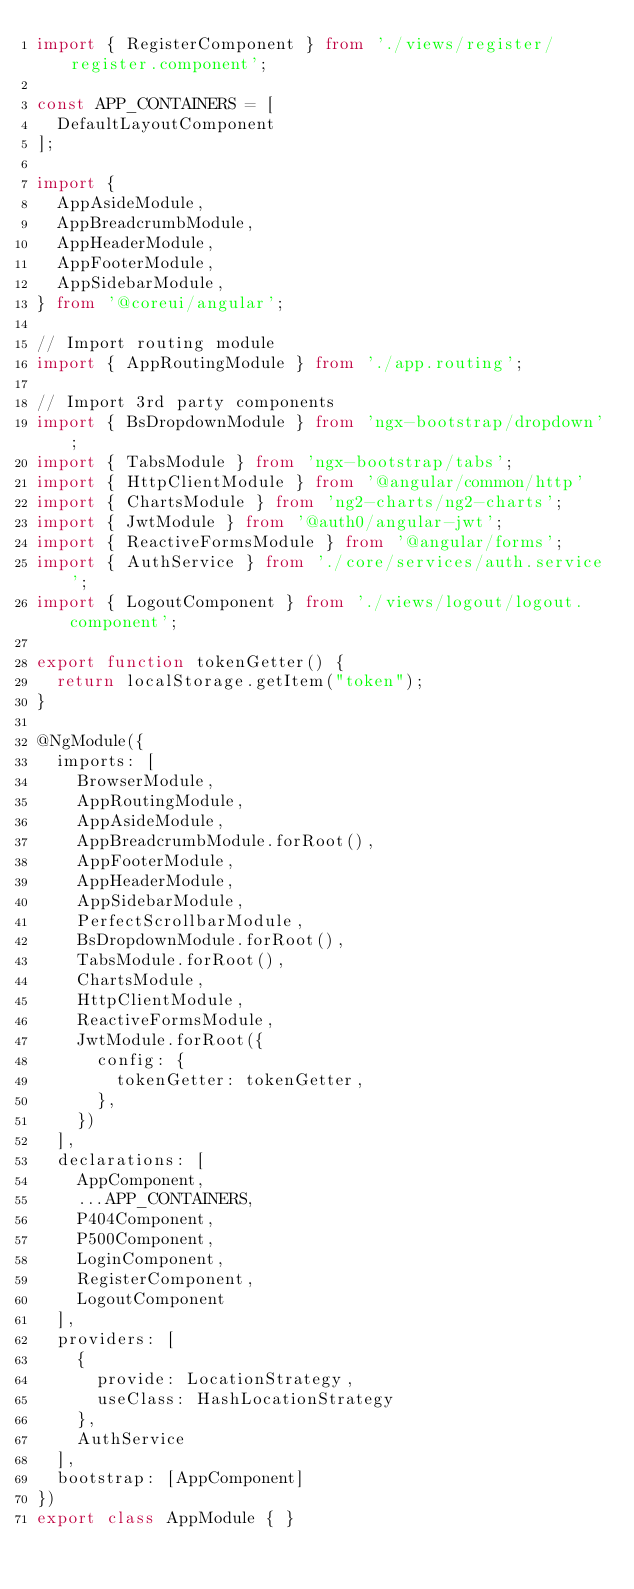<code> <loc_0><loc_0><loc_500><loc_500><_TypeScript_>import { RegisterComponent } from './views/register/register.component';

const APP_CONTAINERS = [
  DefaultLayoutComponent
];

import {
  AppAsideModule,
  AppBreadcrumbModule,
  AppHeaderModule,
  AppFooterModule,
  AppSidebarModule,
} from '@coreui/angular';

// Import routing module
import { AppRoutingModule } from './app.routing';

// Import 3rd party components
import { BsDropdownModule } from 'ngx-bootstrap/dropdown';
import { TabsModule } from 'ngx-bootstrap/tabs';
import { HttpClientModule } from '@angular/common/http'
import { ChartsModule } from 'ng2-charts/ng2-charts';
import { JwtModule } from '@auth0/angular-jwt';
import { ReactiveFormsModule } from '@angular/forms';
import { AuthService } from './core/services/auth.service';
import { LogoutComponent } from './views/logout/logout.component';

export function tokenGetter() {
  return localStorage.getItem("token");
}

@NgModule({
  imports: [
    BrowserModule,
    AppRoutingModule,
    AppAsideModule,
    AppBreadcrumbModule.forRoot(),
    AppFooterModule,
    AppHeaderModule,
    AppSidebarModule,
    PerfectScrollbarModule,
    BsDropdownModule.forRoot(),
    TabsModule.forRoot(),
    ChartsModule,
    HttpClientModule,
    ReactiveFormsModule,
    JwtModule.forRoot({
      config: {
        tokenGetter: tokenGetter,
      },
    })
  ],
  declarations: [
    AppComponent,
    ...APP_CONTAINERS,
    P404Component,
    P500Component,
    LoginComponent,
    RegisterComponent,
    LogoutComponent
  ],
  providers: [
    {
      provide: LocationStrategy,
      useClass: HashLocationStrategy
    },
    AuthService
  ],
  bootstrap: [AppComponent]
})
export class AppModule { }
</code> 